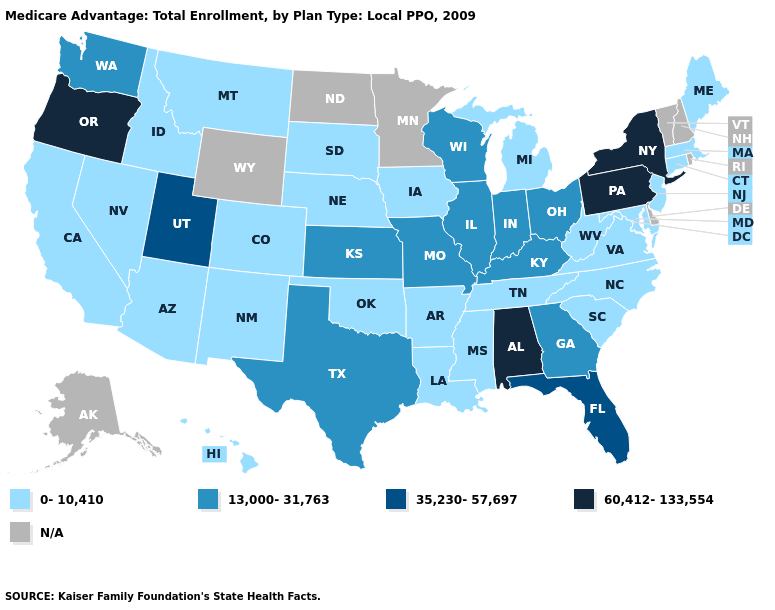Which states have the lowest value in the USA?
Be succinct. Arkansas, Arizona, California, Colorado, Connecticut, Hawaii, Iowa, Idaho, Louisiana, Massachusetts, Maryland, Maine, Michigan, Mississippi, Montana, North Carolina, Nebraska, New Jersey, New Mexico, Nevada, Oklahoma, South Carolina, South Dakota, Tennessee, Virginia, West Virginia. What is the lowest value in the West?
Be succinct. 0-10,410. What is the highest value in the West ?
Quick response, please. 60,412-133,554. What is the value of Alabama?
Short answer required. 60,412-133,554. What is the lowest value in the USA?
Give a very brief answer. 0-10,410. What is the value of South Carolina?
Keep it brief. 0-10,410. Is the legend a continuous bar?
Write a very short answer. No. Which states have the lowest value in the Northeast?
Short answer required. Connecticut, Massachusetts, Maine, New Jersey. Name the states that have a value in the range 13,000-31,763?
Keep it brief. Georgia, Illinois, Indiana, Kansas, Kentucky, Missouri, Ohio, Texas, Washington, Wisconsin. What is the highest value in the USA?
Be succinct. 60,412-133,554. What is the value of Minnesota?
Be succinct. N/A. What is the value of New Jersey?
Concise answer only. 0-10,410. Name the states that have a value in the range N/A?
Be succinct. Alaska, Delaware, Minnesota, North Dakota, New Hampshire, Rhode Island, Vermont, Wyoming. What is the lowest value in the USA?
Write a very short answer. 0-10,410. 